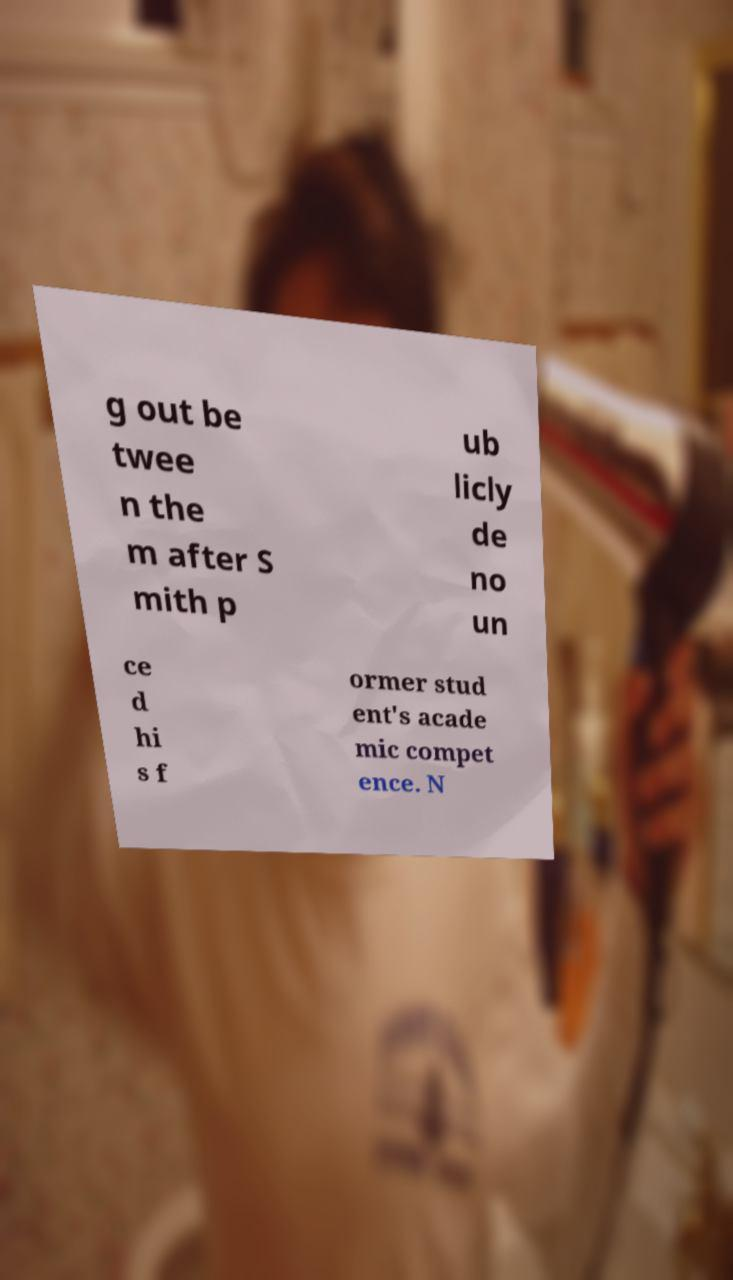I need the written content from this picture converted into text. Can you do that? g out be twee n the m after S mith p ub licly de no un ce d hi s f ormer stud ent's acade mic compet ence. N 